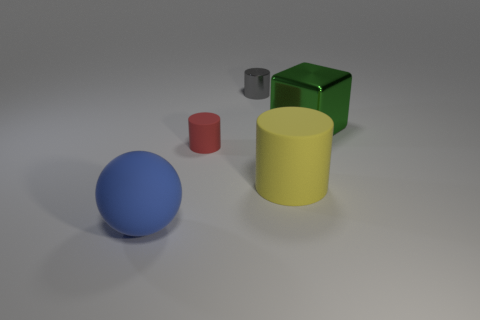Add 3 big red matte balls. How many objects exist? 8 Subtract all blocks. How many objects are left? 4 Add 2 yellow things. How many yellow things are left? 3 Add 1 tiny yellow things. How many tiny yellow things exist? 1 Subtract 1 red cylinders. How many objects are left? 4 Subtract all purple metallic blocks. Subtract all big spheres. How many objects are left? 4 